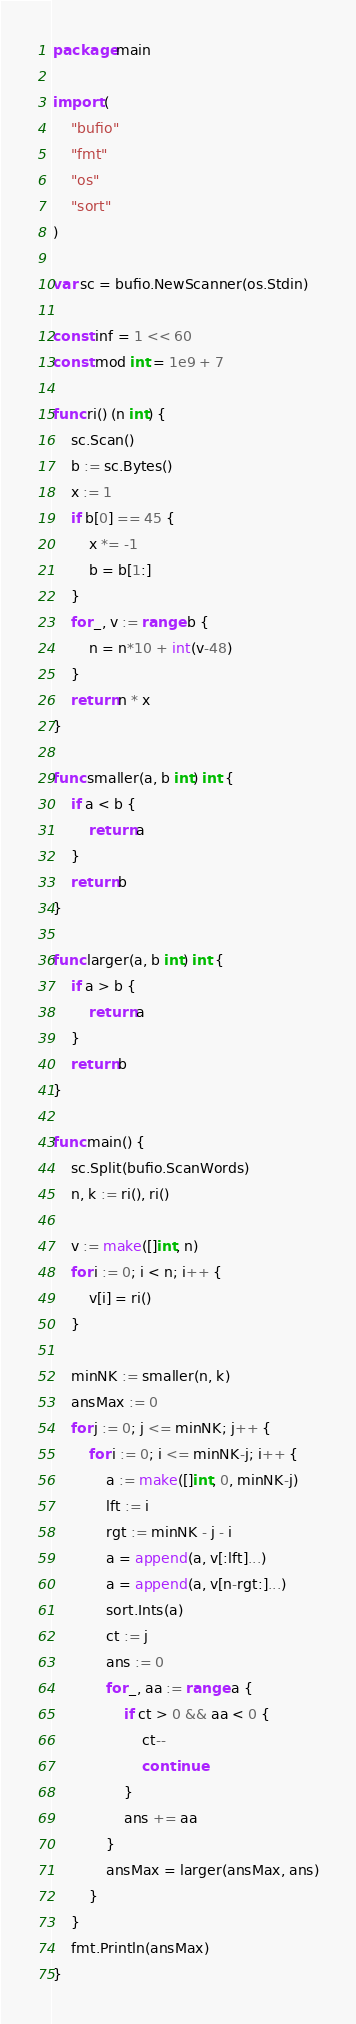<code> <loc_0><loc_0><loc_500><loc_500><_Go_>package main

import (
	"bufio"
	"fmt"
	"os"
	"sort"
)

var sc = bufio.NewScanner(os.Stdin)

const inf = 1 << 60
const mod int = 1e9 + 7

func ri() (n int) {
	sc.Scan()
	b := sc.Bytes()
	x := 1
	if b[0] == 45 {
		x *= -1
		b = b[1:]
	}
	for _, v := range b {
		n = n*10 + int(v-48)
	}
	return n * x
}

func smaller(a, b int) int {
	if a < b {
		return a
	}
	return b
}

func larger(a, b int) int {
	if a > b {
		return a
	}
	return b
}

func main() {
	sc.Split(bufio.ScanWords)
	n, k := ri(), ri()

	v := make([]int, n)
	for i := 0; i < n; i++ {
		v[i] = ri()
	}

	minNK := smaller(n, k)
	ansMax := 0
	for j := 0; j <= minNK; j++ {
		for i := 0; i <= minNK-j; i++ {
			a := make([]int, 0, minNK-j)
			lft := i
			rgt := minNK - j - i
			a = append(a, v[:lft]...)
			a = append(a, v[n-rgt:]...)
			sort.Ints(a)
			ct := j
			ans := 0
			for _, aa := range a {
				if ct > 0 && aa < 0 {
					ct--
					continue
				}
				ans += aa
			}
			ansMax = larger(ansMax, ans)
		}
	}
	fmt.Println(ansMax)
}
</code> 